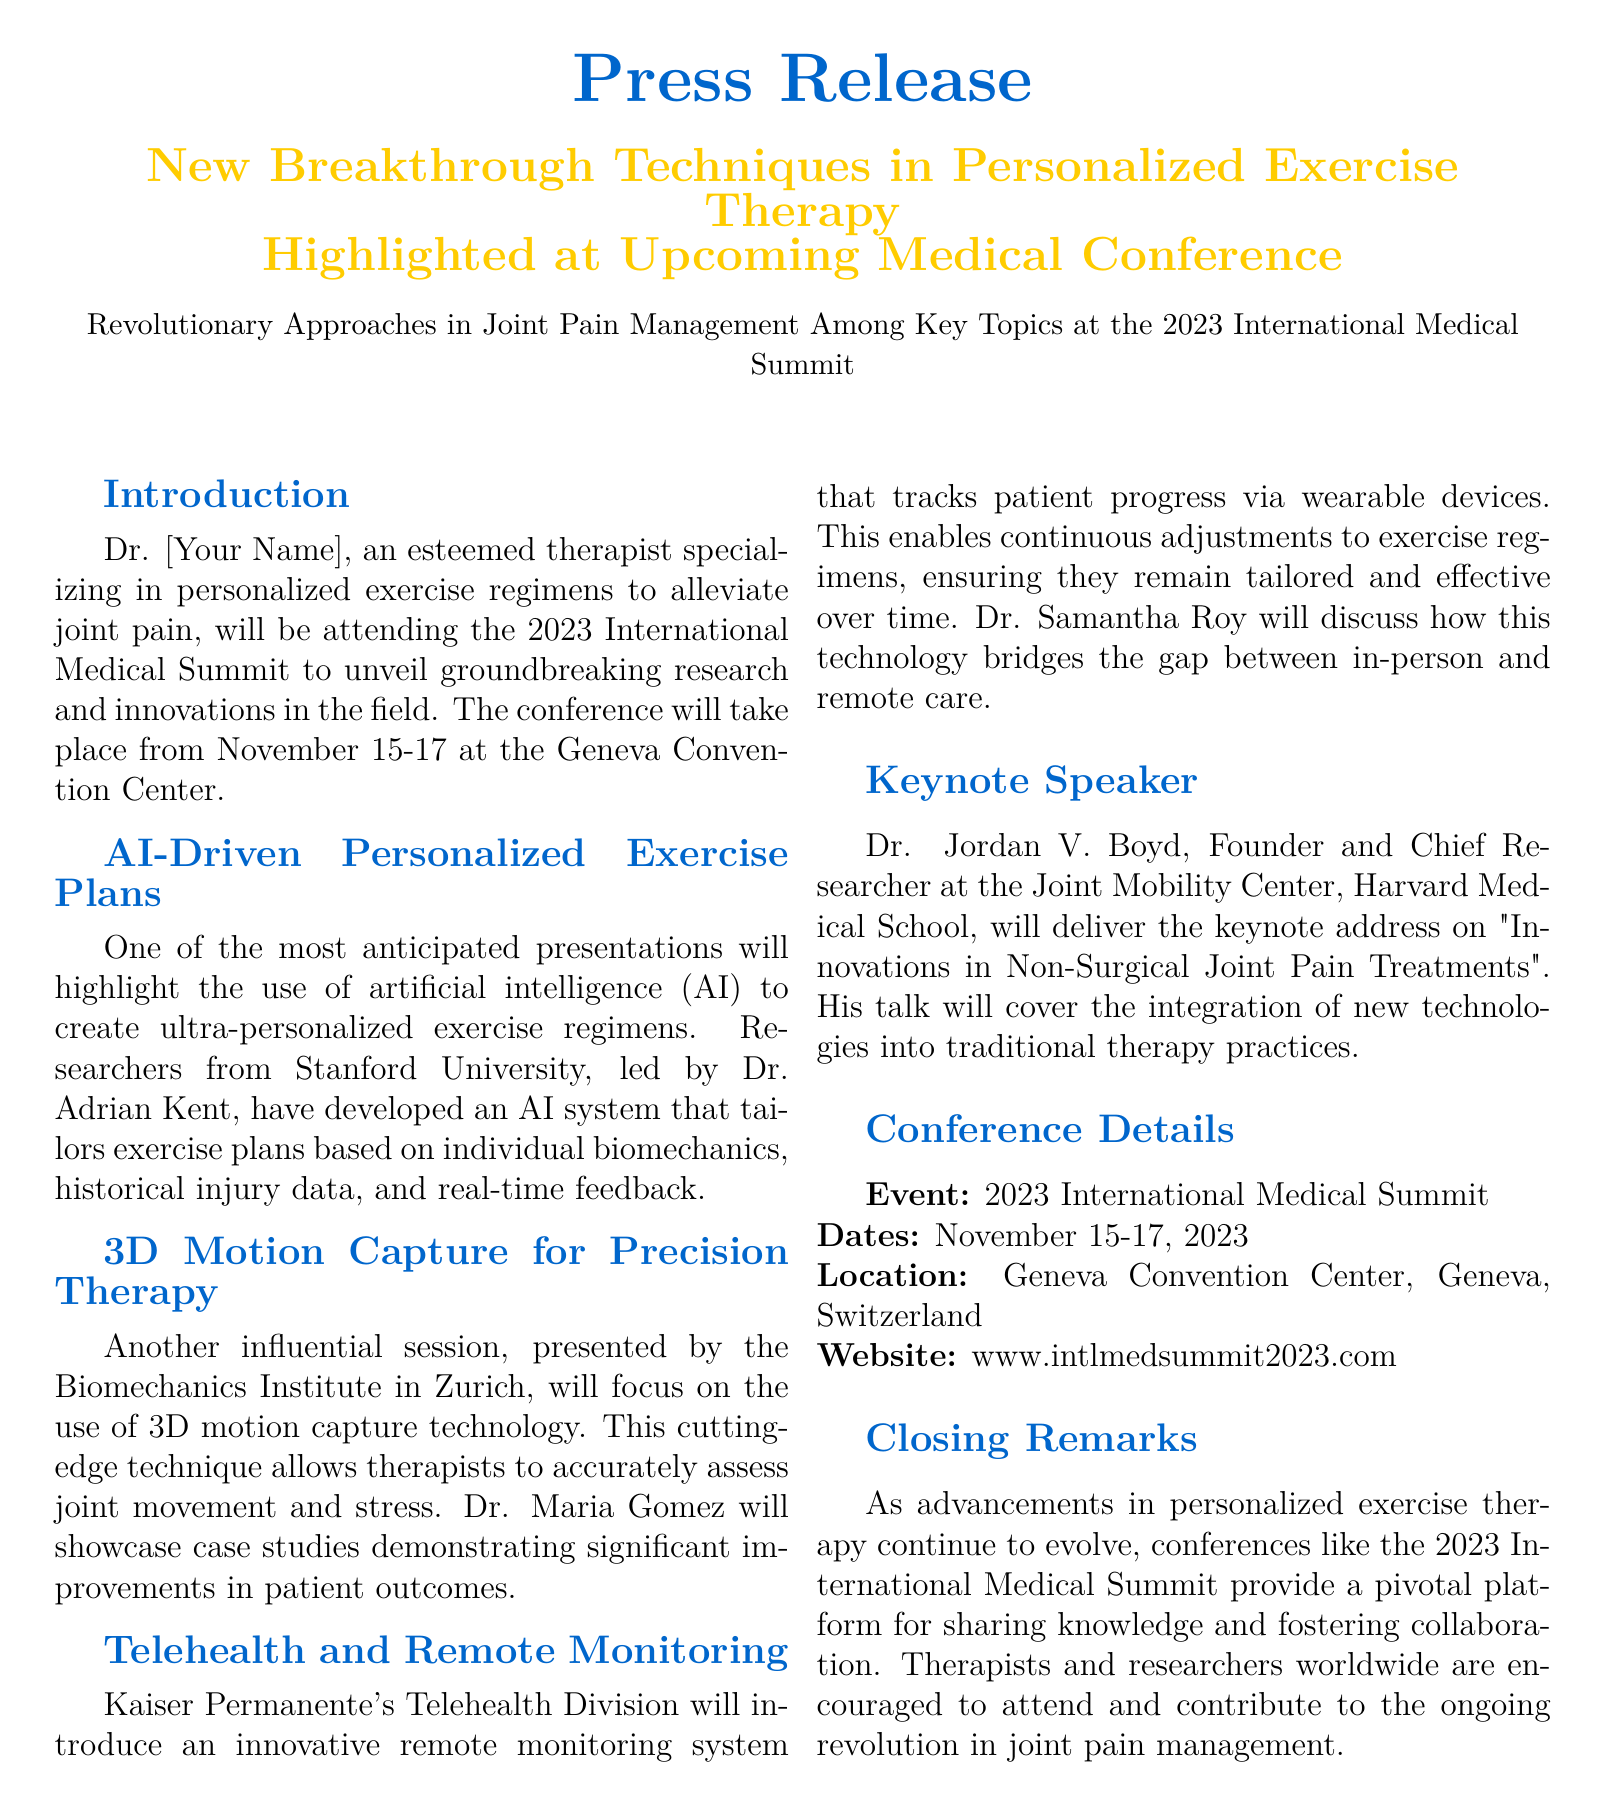What is the name of the conference? The conference is titled the 2023 International Medical Summit, as stated in the document.
Answer: 2023 International Medical Summit Who is the keynote speaker? The document mentions Dr. Jordan V. Boyd as the keynote speaker delivering the address.
Answer: Dr. Jordan V. Boyd What technology is showcased by the Biomechanics Institute? The document states that the Biomechanics Institute focuses on 3D motion capture technology.
Answer: 3D motion capture When does the conference take place? The dates for the conference are mentioned as November 15-17, 2023.
Answer: November 15-17, 2023 What is one feature of the AI-driven exercise plans? The AI-driven exercise plans are based on individual biomechanics, as described in the document.
Answer: Individual biomechanics What organization will present a remote monitoring system? Kaiser Permanente's Telehealth Division is the organization introducing the remote monitoring system.
Answer: Kaiser Permanente What will Dr. Samantha Roy discuss at the conference? Dr. Samantha Roy will discuss how technology bridges the gap between in-person and remote care.
Answer: Technology bridging care gaps What event is highlighted for advancements in joint pain management? The upcoming conference is highlighted for sharing advancements in joint pain management.
Answer: 2023 International Medical Summit 